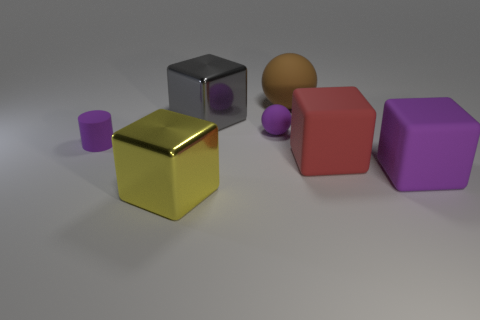What time of day does the lighting in the image suggest? The image has a soft and diffused lighting that does not indicate a clear time of day. It's likely an indoor scene with artificial lighting, given how uniformly the shadows are cast, suggesting a controlled environment rather than natural daylight. 